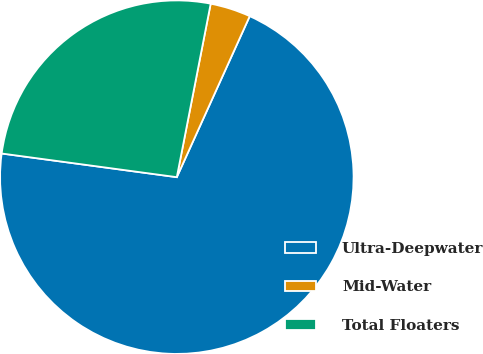Convert chart. <chart><loc_0><loc_0><loc_500><loc_500><pie_chart><fcel>Ultra-Deepwater<fcel>Mid-Water<fcel>Total Floaters<nl><fcel>70.37%<fcel>3.7%<fcel>25.93%<nl></chart> 